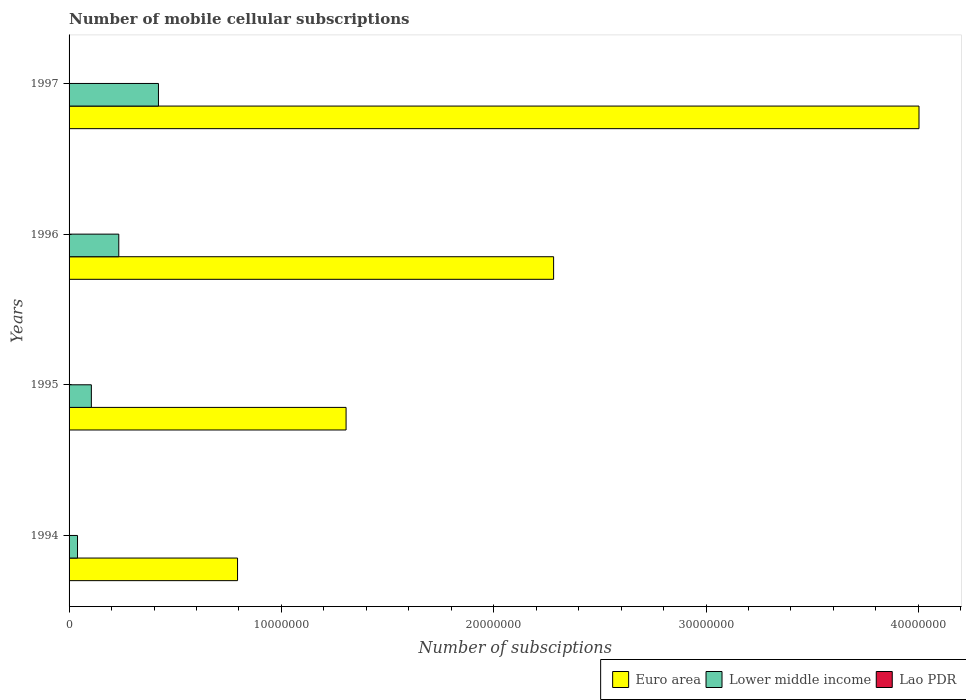How many groups of bars are there?
Make the answer very short. 4. Are the number of bars on each tick of the Y-axis equal?
Offer a terse response. Yes. How many bars are there on the 2nd tick from the top?
Your response must be concise. 3. How many bars are there on the 3rd tick from the bottom?
Your answer should be compact. 3. In how many cases, is the number of bars for a given year not equal to the number of legend labels?
Ensure brevity in your answer.  0. What is the number of mobile cellular subscriptions in Lower middle income in 1995?
Your response must be concise. 1.05e+06. Across all years, what is the maximum number of mobile cellular subscriptions in Lao PDR?
Your response must be concise. 4915. Across all years, what is the minimum number of mobile cellular subscriptions in Lao PDR?
Offer a terse response. 625. In which year was the number of mobile cellular subscriptions in Lower middle income maximum?
Offer a very short reply. 1997. What is the total number of mobile cellular subscriptions in Lower middle income in the graph?
Your answer should be compact. 8.00e+06. What is the difference between the number of mobile cellular subscriptions in Euro area in 1994 and that in 1996?
Keep it short and to the point. -1.49e+07. What is the difference between the number of mobile cellular subscriptions in Euro area in 1996 and the number of mobile cellular subscriptions in Lower middle income in 1995?
Offer a very short reply. 2.18e+07. What is the average number of mobile cellular subscriptions in Euro area per year?
Keep it short and to the point. 2.10e+07. In the year 1994, what is the difference between the number of mobile cellular subscriptions in Euro area and number of mobile cellular subscriptions in Lao PDR?
Make the answer very short. 7.93e+06. In how many years, is the number of mobile cellular subscriptions in Lao PDR greater than 6000000 ?
Your response must be concise. 0. What is the ratio of the number of mobile cellular subscriptions in Euro area in 1994 to that in 1997?
Ensure brevity in your answer.  0.2. Is the number of mobile cellular subscriptions in Lower middle income in 1995 less than that in 1997?
Your response must be concise. Yes. What is the difference between the highest and the second highest number of mobile cellular subscriptions in Lower middle income?
Provide a succinct answer. 1.87e+06. What is the difference between the highest and the lowest number of mobile cellular subscriptions in Lower middle income?
Your answer should be compact. 3.81e+06. In how many years, is the number of mobile cellular subscriptions in Lao PDR greater than the average number of mobile cellular subscriptions in Lao PDR taken over all years?
Keep it short and to the point. 2. Is the sum of the number of mobile cellular subscriptions in Lower middle income in 1995 and 1997 greater than the maximum number of mobile cellular subscriptions in Euro area across all years?
Give a very brief answer. No. What does the 2nd bar from the bottom in 1995 represents?
Give a very brief answer. Lower middle income. How many bars are there?
Provide a short and direct response. 12. How many years are there in the graph?
Your answer should be very brief. 4. Are the values on the major ticks of X-axis written in scientific E-notation?
Offer a terse response. No. Does the graph contain grids?
Offer a terse response. No. How are the legend labels stacked?
Offer a very short reply. Horizontal. What is the title of the graph?
Keep it short and to the point. Number of mobile cellular subscriptions. What is the label or title of the X-axis?
Provide a succinct answer. Number of subsciptions. What is the Number of subsciptions in Euro area in 1994?
Keep it short and to the point. 7.94e+06. What is the Number of subsciptions of Lower middle income in 1994?
Your answer should be very brief. 3.98e+05. What is the Number of subsciptions in Lao PDR in 1994?
Provide a short and direct response. 625. What is the Number of subsciptions in Euro area in 1995?
Your answer should be very brief. 1.30e+07. What is the Number of subsciptions of Lower middle income in 1995?
Ensure brevity in your answer.  1.05e+06. What is the Number of subsciptions of Lao PDR in 1995?
Give a very brief answer. 1539. What is the Number of subsciptions of Euro area in 1996?
Offer a very short reply. 2.28e+07. What is the Number of subsciptions of Lower middle income in 1996?
Your response must be concise. 2.34e+06. What is the Number of subsciptions of Lao PDR in 1996?
Offer a terse response. 3790. What is the Number of subsciptions of Euro area in 1997?
Ensure brevity in your answer.  4.00e+07. What is the Number of subsciptions of Lower middle income in 1997?
Your answer should be compact. 4.21e+06. What is the Number of subsciptions of Lao PDR in 1997?
Your answer should be compact. 4915. Across all years, what is the maximum Number of subsciptions of Euro area?
Keep it short and to the point. 4.00e+07. Across all years, what is the maximum Number of subsciptions of Lower middle income?
Provide a short and direct response. 4.21e+06. Across all years, what is the maximum Number of subsciptions of Lao PDR?
Offer a very short reply. 4915. Across all years, what is the minimum Number of subsciptions in Euro area?
Your answer should be very brief. 7.94e+06. Across all years, what is the minimum Number of subsciptions in Lower middle income?
Provide a succinct answer. 3.98e+05. Across all years, what is the minimum Number of subsciptions in Lao PDR?
Offer a very short reply. 625. What is the total Number of subsciptions of Euro area in the graph?
Make the answer very short. 8.38e+07. What is the total Number of subsciptions in Lower middle income in the graph?
Offer a very short reply. 8.00e+06. What is the total Number of subsciptions in Lao PDR in the graph?
Offer a very short reply. 1.09e+04. What is the difference between the Number of subsciptions of Euro area in 1994 and that in 1995?
Offer a very short reply. -5.11e+06. What is the difference between the Number of subsciptions of Lower middle income in 1994 and that in 1995?
Ensure brevity in your answer.  -6.51e+05. What is the difference between the Number of subsciptions of Lao PDR in 1994 and that in 1995?
Provide a succinct answer. -914. What is the difference between the Number of subsciptions in Euro area in 1994 and that in 1996?
Your answer should be very brief. -1.49e+07. What is the difference between the Number of subsciptions in Lower middle income in 1994 and that in 1996?
Ensure brevity in your answer.  -1.94e+06. What is the difference between the Number of subsciptions of Lao PDR in 1994 and that in 1996?
Give a very brief answer. -3165. What is the difference between the Number of subsciptions of Euro area in 1994 and that in 1997?
Keep it short and to the point. -3.21e+07. What is the difference between the Number of subsciptions of Lower middle income in 1994 and that in 1997?
Provide a short and direct response. -3.81e+06. What is the difference between the Number of subsciptions of Lao PDR in 1994 and that in 1997?
Provide a succinct answer. -4290. What is the difference between the Number of subsciptions in Euro area in 1995 and that in 1996?
Offer a terse response. -9.77e+06. What is the difference between the Number of subsciptions in Lower middle income in 1995 and that in 1996?
Make the answer very short. -1.29e+06. What is the difference between the Number of subsciptions in Lao PDR in 1995 and that in 1996?
Offer a terse response. -2251. What is the difference between the Number of subsciptions in Euro area in 1995 and that in 1997?
Keep it short and to the point. -2.70e+07. What is the difference between the Number of subsciptions in Lower middle income in 1995 and that in 1997?
Provide a short and direct response. -3.16e+06. What is the difference between the Number of subsciptions of Lao PDR in 1995 and that in 1997?
Provide a short and direct response. -3376. What is the difference between the Number of subsciptions of Euro area in 1996 and that in 1997?
Your response must be concise. -1.72e+07. What is the difference between the Number of subsciptions of Lower middle income in 1996 and that in 1997?
Your answer should be very brief. -1.87e+06. What is the difference between the Number of subsciptions in Lao PDR in 1996 and that in 1997?
Provide a succinct answer. -1125. What is the difference between the Number of subsciptions of Euro area in 1994 and the Number of subsciptions of Lower middle income in 1995?
Your response must be concise. 6.89e+06. What is the difference between the Number of subsciptions in Euro area in 1994 and the Number of subsciptions in Lao PDR in 1995?
Offer a terse response. 7.93e+06. What is the difference between the Number of subsciptions in Lower middle income in 1994 and the Number of subsciptions in Lao PDR in 1995?
Your response must be concise. 3.96e+05. What is the difference between the Number of subsciptions in Euro area in 1994 and the Number of subsciptions in Lower middle income in 1996?
Offer a very short reply. 5.59e+06. What is the difference between the Number of subsciptions of Euro area in 1994 and the Number of subsciptions of Lao PDR in 1996?
Offer a terse response. 7.93e+06. What is the difference between the Number of subsciptions in Lower middle income in 1994 and the Number of subsciptions in Lao PDR in 1996?
Offer a very short reply. 3.94e+05. What is the difference between the Number of subsciptions in Euro area in 1994 and the Number of subsciptions in Lower middle income in 1997?
Your response must be concise. 3.73e+06. What is the difference between the Number of subsciptions of Euro area in 1994 and the Number of subsciptions of Lao PDR in 1997?
Keep it short and to the point. 7.93e+06. What is the difference between the Number of subsciptions of Lower middle income in 1994 and the Number of subsciptions of Lao PDR in 1997?
Make the answer very short. 3.93e+05. What is the difference between the Number of subsciptions of Euro area in 1995 and the Number of subsciptions of Lower middle income in 1996?
Give a very brief answer. 1.07e+07. What is the difference between the Number of subsciptions in Euro area in 1995 and the Number of subsciptions in Lao PDR in 1996?
Offer a very short reply. 1.30e+07. What is the difference between the Number of subsciptions in Lower middle income in 1995 and the Number of subsciptions in Lao PDR in 1996?
Your answer should be compact. 1.05e+06. What is the difference between the Number of subsciptions in Euro area in 1995 and the Number of subsciptions in Lower middle income in 1997?
Make the answer very short. 8.84e+06. What is the difference between the Number of subsciptions in Euro area in 1995 and the Number of subsciptions in Lao PDR in 1997?
Your response must be concise. 1.30e+07. What is the difference between the Number of subsciptions of Lower middle income in 1995 and the Number of subsciptions of Lao PDR in 1997?
Your answer should be compact. 1.04e+06. What is the difference between the Number of subsciptions of Euro area in 1996 and the Number of subsciptions of Lower middle income in 1997?
Keep it short and to the point. 1.86e+07. What is the difference between the Number of subsciptions in Euro area in 1996 and the Number of subsciptions in Lao PDR in 1997?
Provide a short and direct response. 2.28e+07. What is the difference between the Number of subsciptions of Lower middle income in 1996 and the Number of subsciptions of Lao PDR in 1997?
Ensure brevity in your answer.  2.34e+06. What is the average Number of subsciptions of Euro area per year?
Give a very brief answer. 2.10e+07. What is the average Number of subsciptions of Lower middle income per year?
Ensure brevity in your answer.  2.00e+06. What is the average Number of subsciptions in Lao PDR per year?
Ensure brevity in your answer.  2717.25. In the year 1994, what is the difference between the Number of subsciptions of Euro area and Number of subsciptions of Lower middle income?
Offer a terse response. 7.54e+06. In the year 1994, what is the difference between the Number of subsciptions in Euro area and Number of subsciptions in Lao PDR?
Make the answer very short. 7.93e+06. In the year 1994, what is the difference between the Number of subsciptions of Lower middle income and Number of subsciptions of Lao PDR?
Provide a succinct answer. 3.97e+05. In the year 1995, what is the difference between the Number of subsciptions of Euro area and Number of subsciptions of Lower middle income?
Give a very brief answer. 1.20e+07. In the year 1995, what is the difference between the Number of subsciptions in Euro area and Number of subsciptions in Lao PDR?
Make the answer very short. 1.30e+07. In the year 1995, what is the difference between the Number of subsciptions in Lower middle income and Number of subsciptions in Lao PDR?
Give a very brief answer. 1.05e+06. In the year 1996, what is the difference between the Number of subsciptions in Euro area and Number of subsciptions in Lower middle income?
Make the answer very short. 2.05e+07. In the year 1996, what is the difference between the Number of subsciptions in Euro area and Number of subsciptions in Lao PDR?
Make the answer very short. 2.28e+07. In the year 1996, what is the difference between the Number of subsciptions of Lower middle income and Number of subsciptions of Lao PDR?
Offer a very short reply. 2.34e+06. In the year 1997, what is the difference between the Number of subsciptions in Euro area and Number of subsciptions in Lower middle income?
Your answer should be very brief. 3.58e+07. In the year 1997, what is the difference between the Number of subsciptions in Euro area and Number of subsciptions in Lao PDR?
Your answer should be very brief. 4.00e+07. In the year 1997, what is the difference between the Number of subsciptions of Lower middle income and Number of subsciptions of Lao PDR?
Offer a very short reply. 4.21e+06. What is the ratio of the Number of subsciptions in Euro area in 1994 to that in 1995?
Your response must be concise. 0.61. What is the ratio of the Number of subsciptions in Lower middle income in 1994 to that in 1995?
Your answer should be compact. 0.38. What is the ratio of the Number of subsciptions of Lao PDR in 1994 to that in 1995?
Your answer should be very brief. 0.41. What is the ratio of the Number of subsciptions in Euro area in 1994 to that in 1996?
Your response must be concise. 0.35. What is the ratio of the Number of subsciptions in Lower middle income in 1994 to that in 1996?
Offer a very short reply. 0.17. What is the ratio of the Number of subsciptions of Lao PDR in 1994 to that in 1996?
Provide a succinct answer. 0.16. What is the ratio of the Number of subsciptions in Euro area in 1994 to that in 1997?
Give a very brief answer. 0.2. What is the ratio of the Number of subsciptions in Lower middle income in 1994 to that in 1997?
Keep it short and to the point. 0.09. What is the ratio of the Number of subsciptions of Lao PDR in 1994 to that in 1997?
Your answer should be compact. 0.13. What is the ratio of the Number of subsciptions in Euro area in 1995 to that in 1996?
Your answer should be compact. 0.57. What is the ratio of the Number of subsciptions of Lower middle income in 1995 to that in 1996?
Offer a terse response. 0.45. What is the ratio of the Number of subsciptions of Lao PDR in 1995 to that in 1996?
Provide a succinct answer. 0.41. What is the ratio of the Number of subsciptions in Euro area in 1995 to that in 1997?
Keep it short and to the point. 0.33. What is the ratio of the Number of subsciptions of Lower middle income in 1995 to that in 1997?
Your response must be concise. 0.25. What is the ratio of the Number of subsciptions in Lao PDR in 1995 to that in 1997?
Provide a succinct answer. 0.31. What is the ratio of the Number of subsciptions of Euro area in 1996 to that in 1997?
Your answer should be very brief. 0.57. What is the ratio of the Number of subsciptions of Lower middle income in 1996 to that in 1997?
Your answer should be very brief. 0.56. What is the ratio of the Number of subsciptions in Lao PDR in 1996 to that in 1997?
Your response must be concise. 0.77. What is the difference between the highest and the second highest Number of subsciptions in Euro area?
Offer a terse response. 1.72e+07. What is the difference between the highest and the second highest Number of subsciptions of Lower middle income?
Make the answer very short. 1.87e+06. What is the difference between the highest and the second highest Number of subsciptions of Lao PDR?
Offer a terse response. 1125. What is the difference between the highest and the lowest Number of subsciptions in Euro area?
Your answer should be compact. 3.21e+07. What is the difference between the highest and the lowest Number of subsciptions in Lower middle income?
Make the answer very short. 3.81e+06. What is the difference between the highest and the lowest Number of subsciptions in Lao PDR?
Your response must be concise. 4290. 